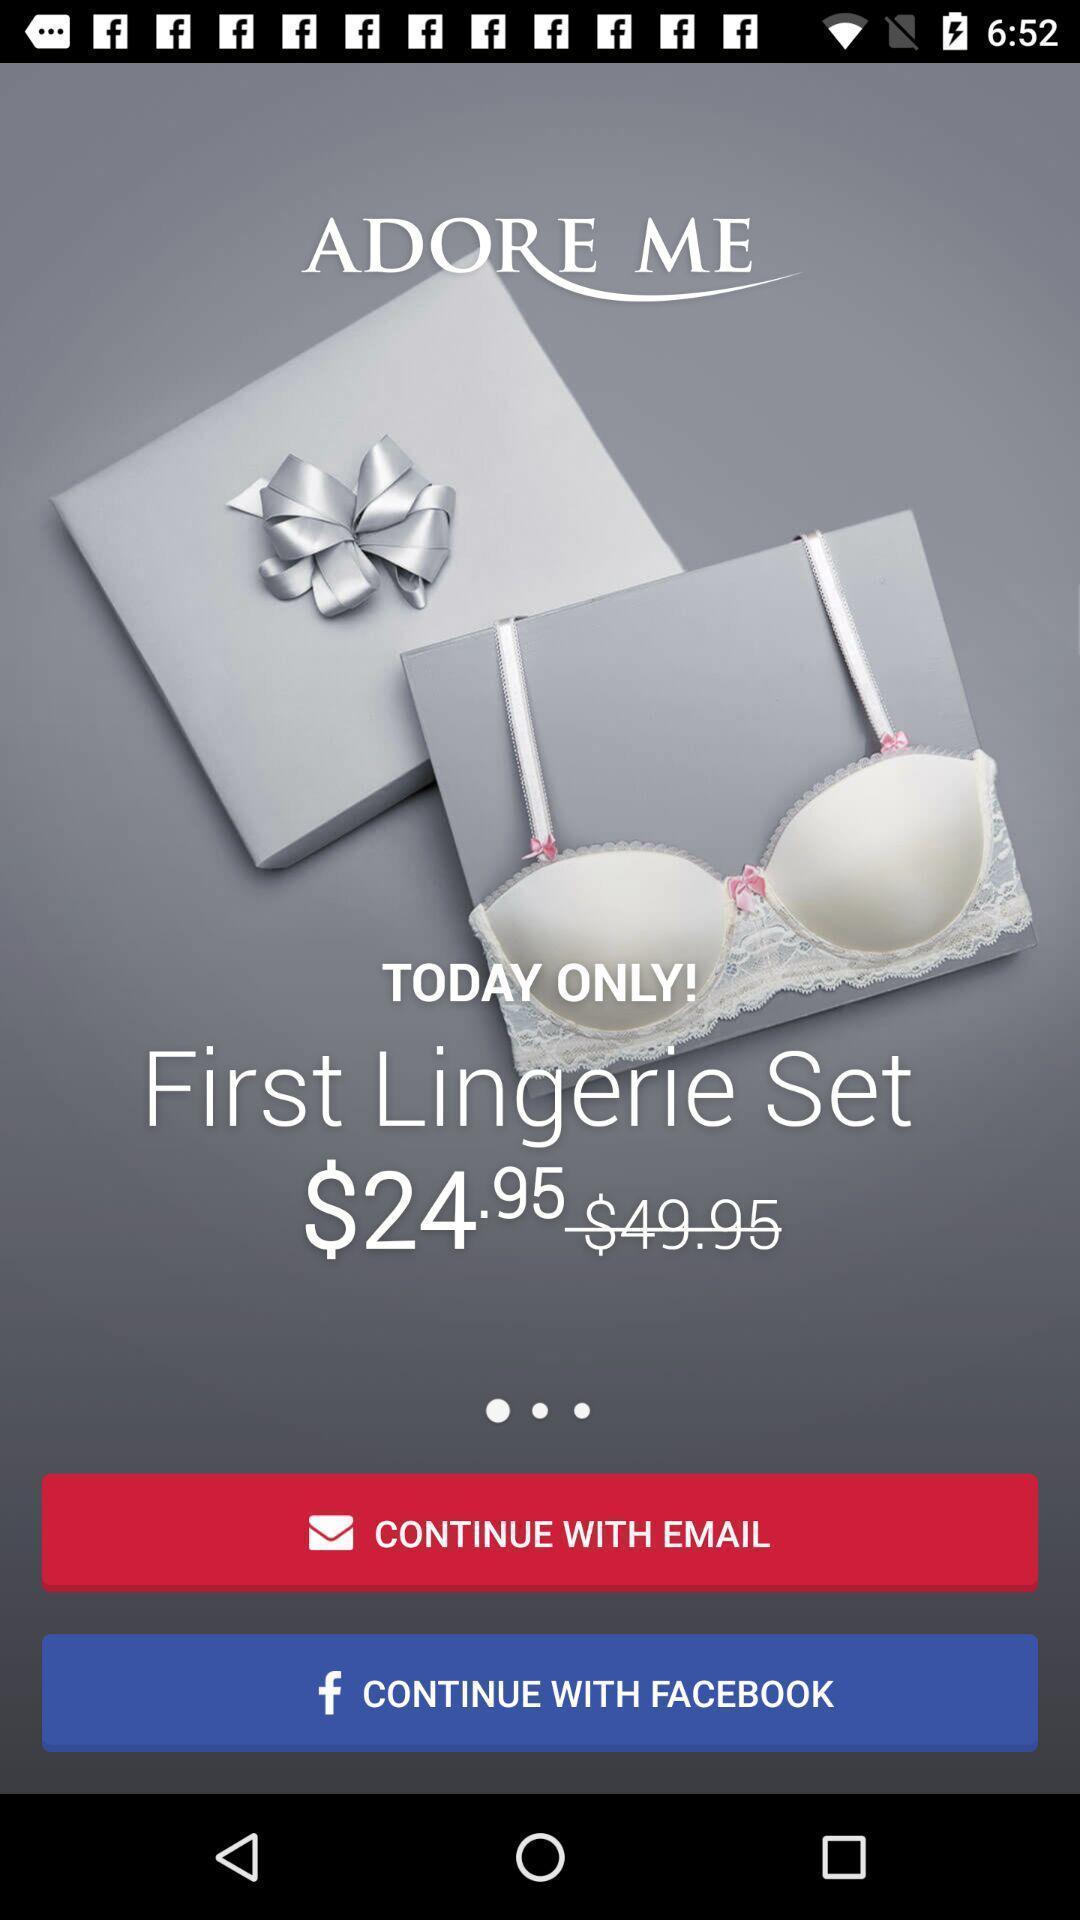Summarize the main components in this picture. Welcome page of shopping app. 